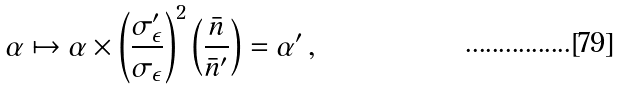Convert formula to latex. <formula><loc_0><loc_0><loc_500><loc_500>\alpha \mapsto \alpha \times \left ( \frac { \sigma ^ { \prime } _ { \epsilon } } { \sigma _ { \epsilon } } \right ) ^ { 2 } \left ( \frac { \bar { n } } { \bar { n } ^ { \prime } } \right ) = \alpha ^ { \prime } \, ,</formula> 